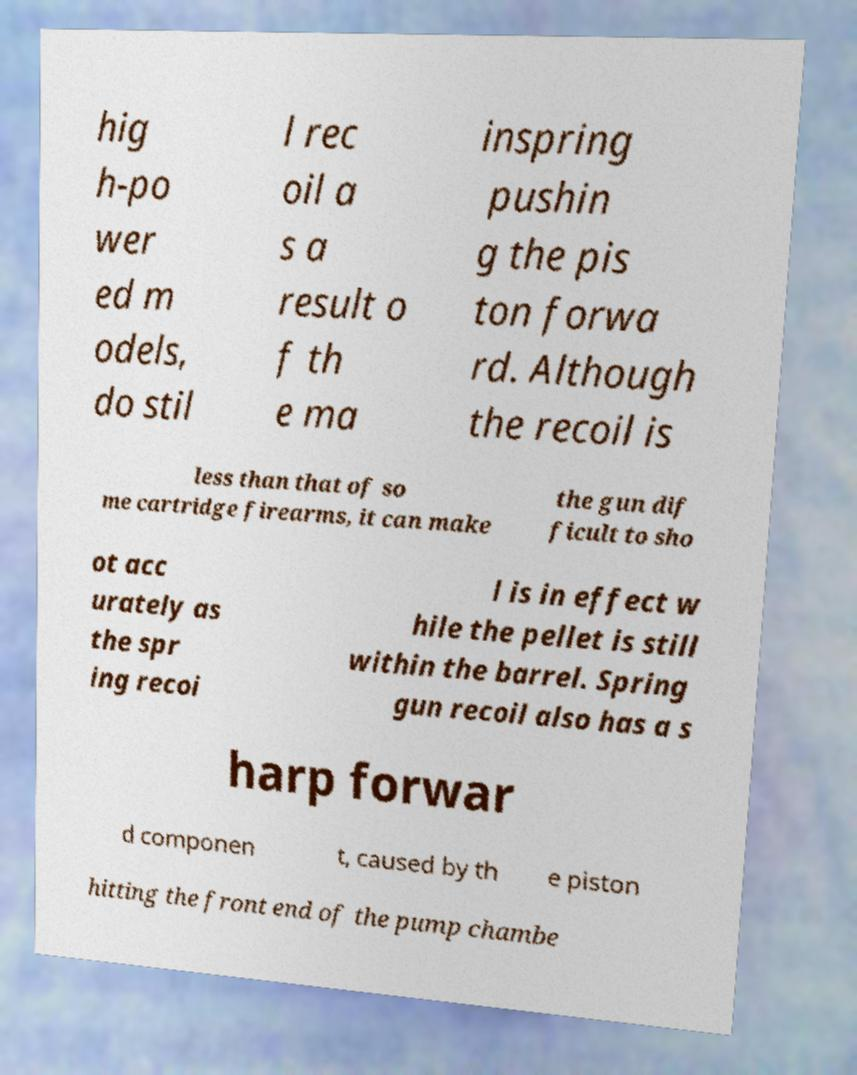Please identify and transcribe the text found in this image. hig h-po wer ed m odels, do stil l rec oil a s a result o f th e ma inspring pushin g the pis ton forwa rd. Although the recoil is less than that of so me cartridge firearms, it can make the gun dif ficult to sho ot acc urately as the spr ing recoi l is in effect w hile the pellet is still within the barrel. Spring gun recoil also has a s harp forwar d componen t, caused by th e piston hitting the front end of the pump chambe 